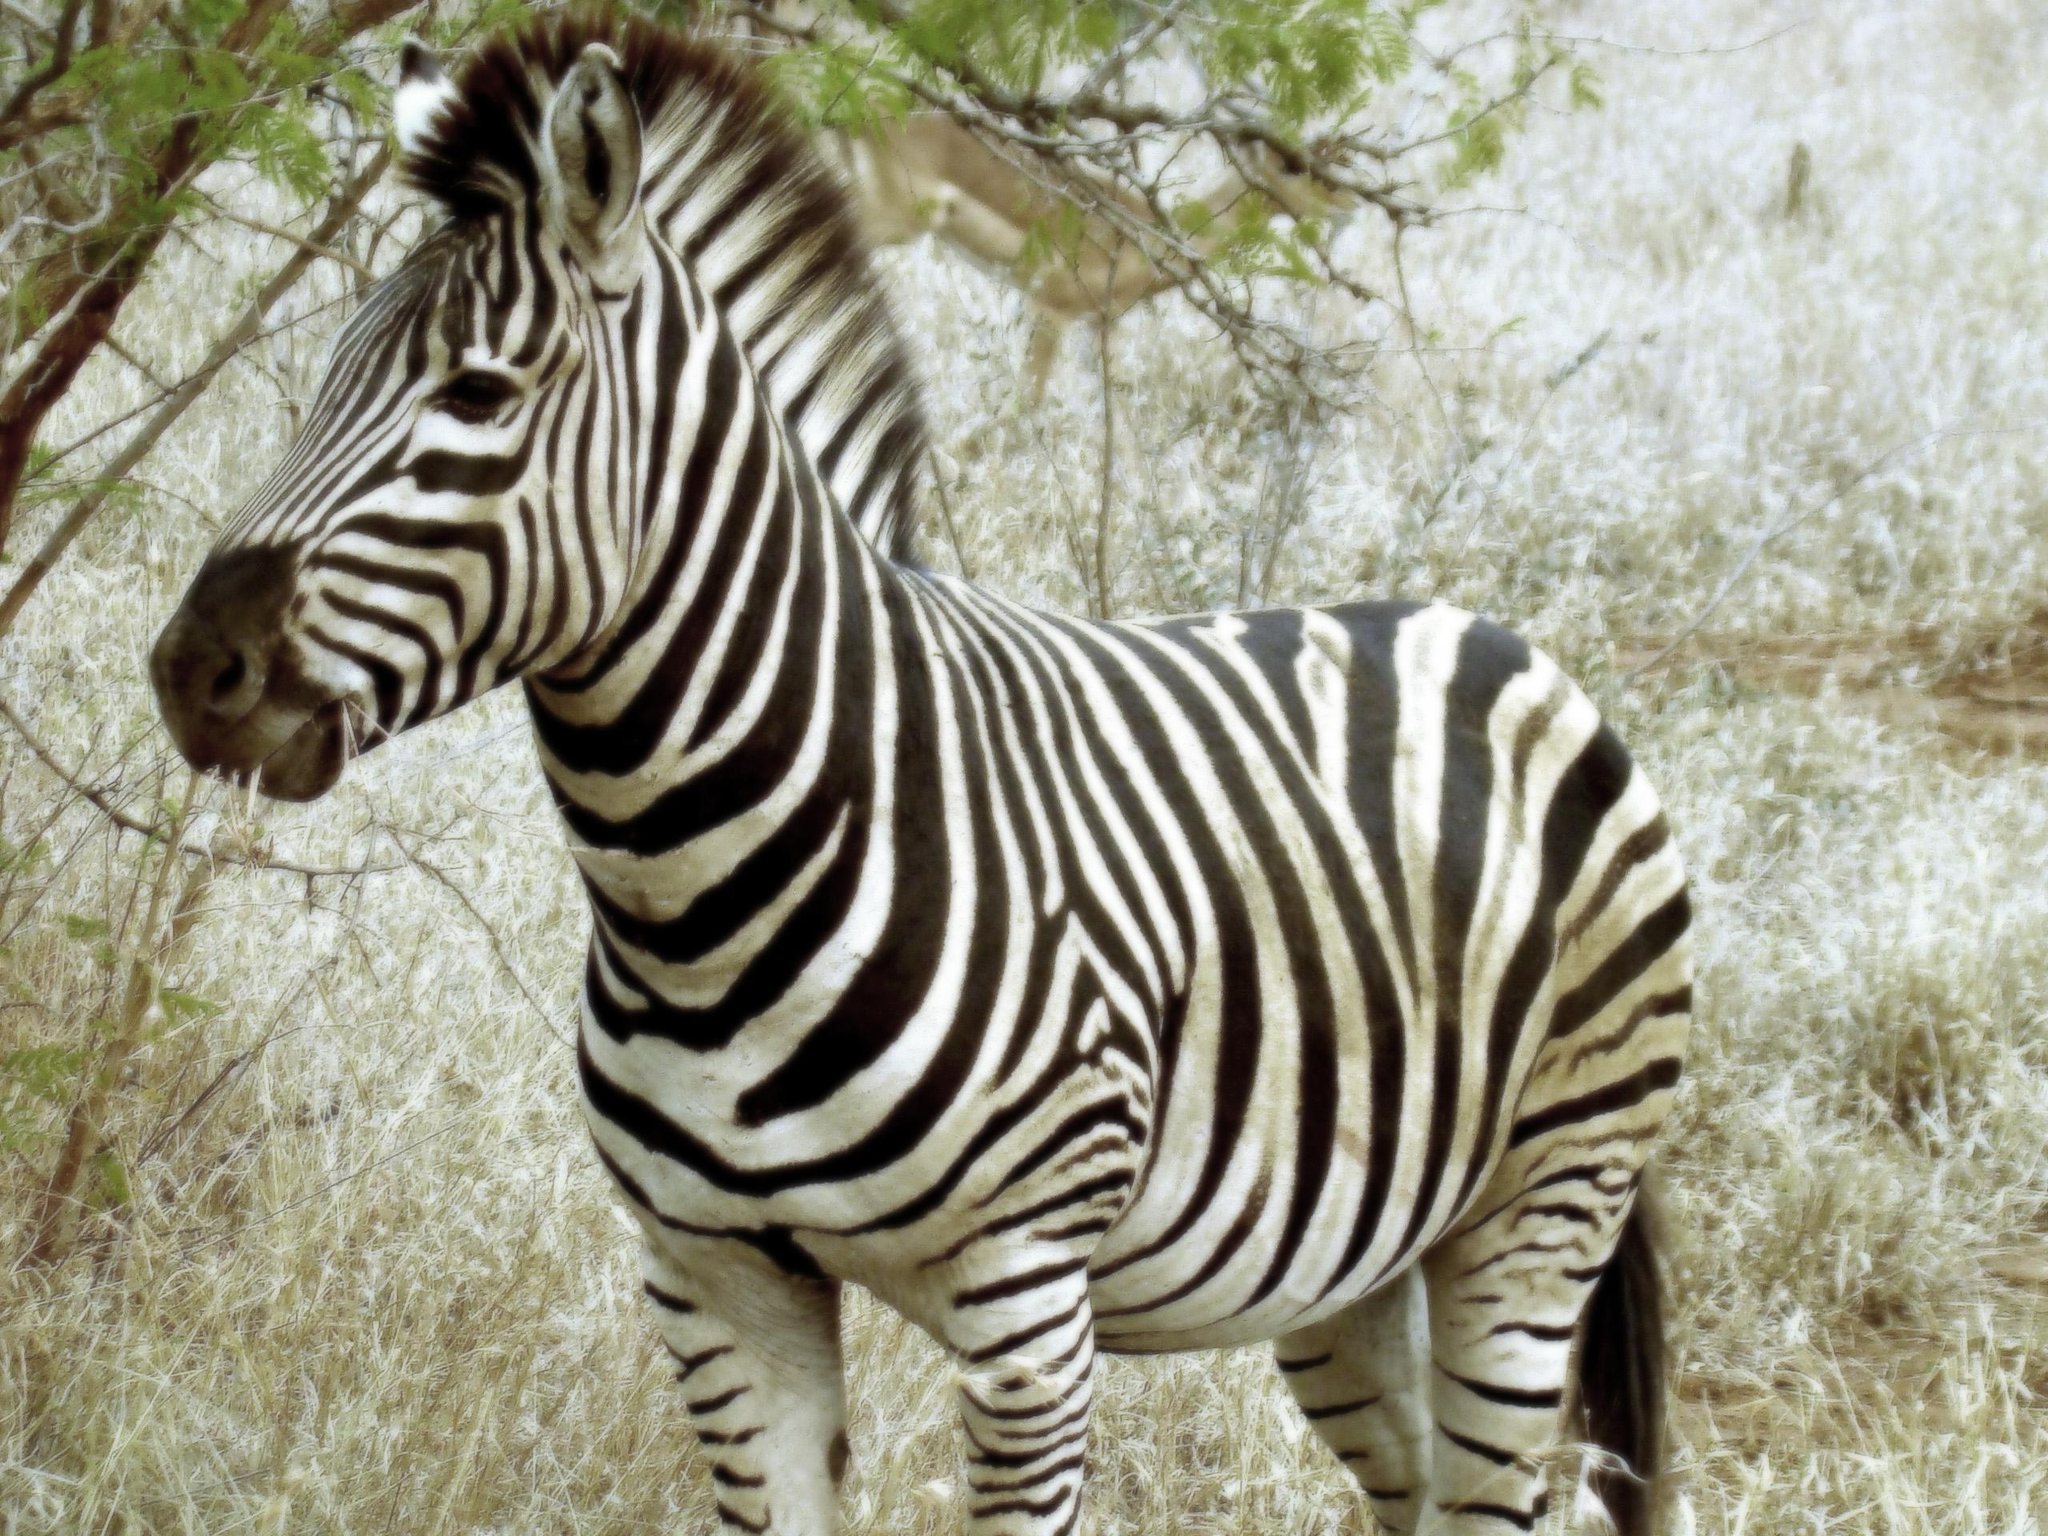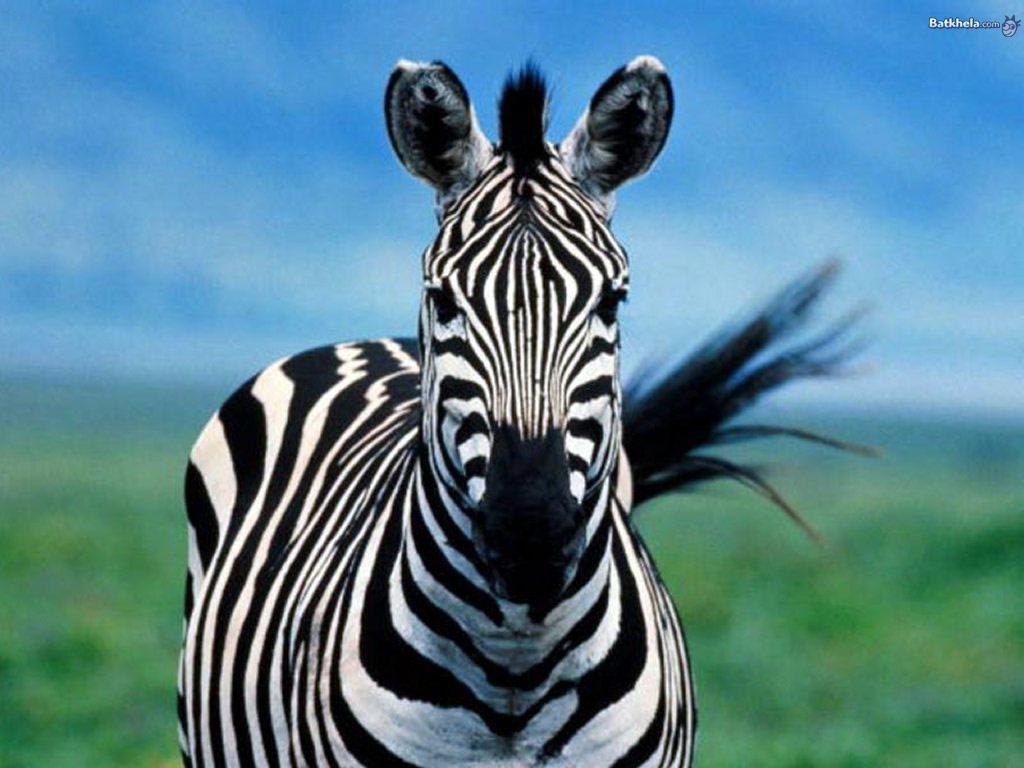The first image is the image on the left, the second image is the image on the right. For the images shown, is this caption "A young zebra can be seen with at least one adult zebra in one of the images." true? Answer yes or no. No. The first image is the image on the left, the second image is the image on the right. Considering the images on both sides, is "In one image, two similarly-sized zebras are standing side by side in the same direction." valid? Answer yes or no. No. 